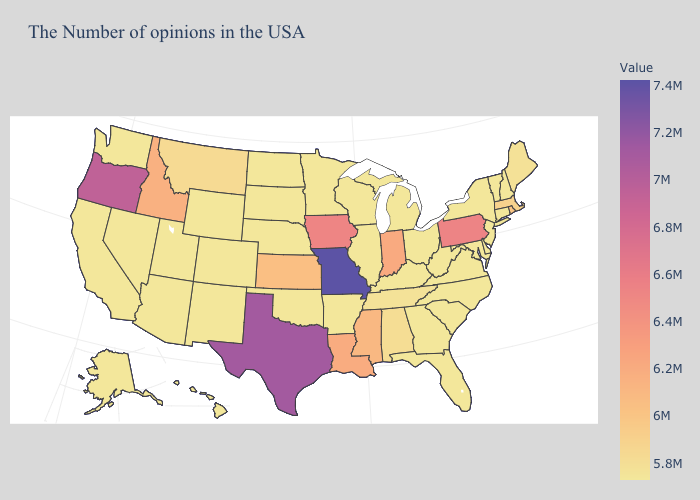Which states have the highest value in the USA?
Write a very short answer. Missouri. Does New York have the lowest value in the Northeast?
Keep it brief. Yes. Among the states that border Virginia , does Tennessee have the lowest value?
Answer briefly. No. Does Montana have the lowest value in the USA?
Answer briefly. No. Which states have the lowest value in the Northeast?
Quick response, please. New Hampshire, Vermont, Connecticut, New York, New Jersey. Does Pennsylvania have the highest value in the Northeast?
Short answer required. Yes. 